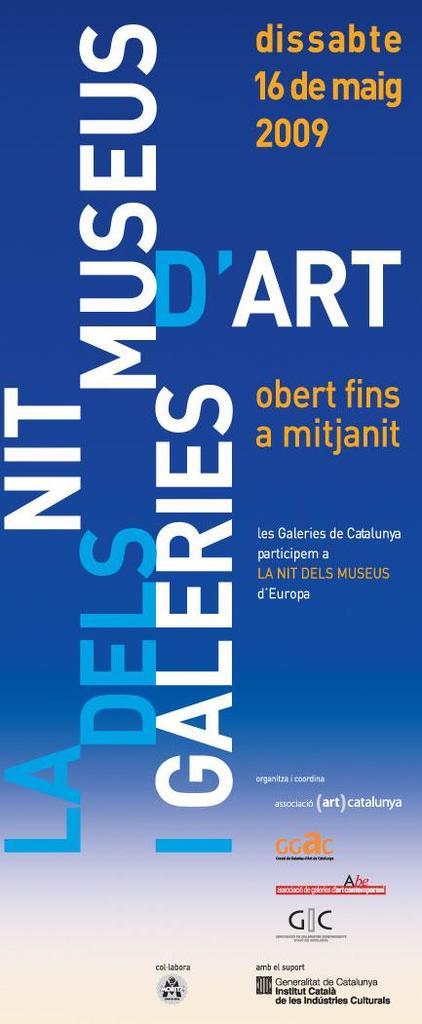What year was this poster?
Your answer should be compact. 2009. What kind of show is being advertised?
Your answer should be very brief. Art. 